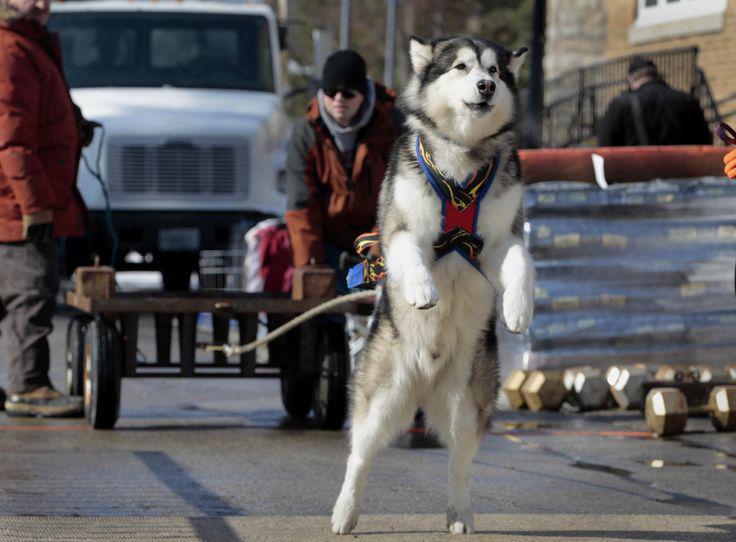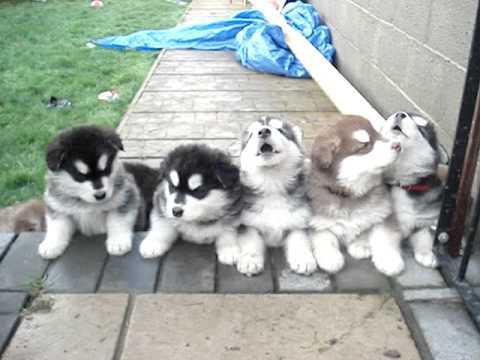The first image is the image on the left, the second image is the image on the right. Given the left and right images, does the statement "One of the images shows exactly five puppies." hold true? Answer yes or no. Yes. The first image is the image on the left, the second image is the image on the right. Analyze the images presented: Is the assertion "At least one person is standing directly next to a standing, leftward-facing husky in the left image." valid? Answer yes or no. No. 